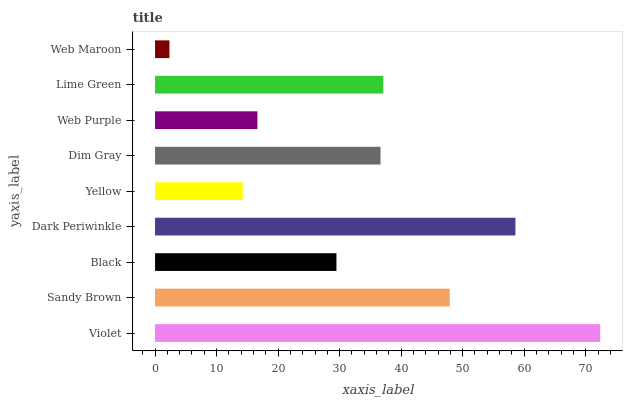Is Web Maroon the minimum?
Answer yes or no. Yes. Is Violet the maximum?
Answer yes or no. Yes. Is Sandy Brown the minimum?
Answer yes or no. No. Is Sandy Brown the maximum?
Answer yes or no. No. Is Violet greater than Sandy Brown?
Answer yes or no. Yes. Is Sandy Brown less than Violet?
Answer yes or no. Yes. Is Sandy Brown greater than Violet?
Answer yes or no. No. Is Violet less than Sandy Brown?
Answer yes or no. No. Is Dim Gray the high median?
Answer yes or no. Yes. Is Dim Gray the low median?
Answer yes or no. Yes. Is Dark Periwinkle the high median?
Answer yes or no. No. Is Sandy Brown the low median?
Answer yes or no. No. 